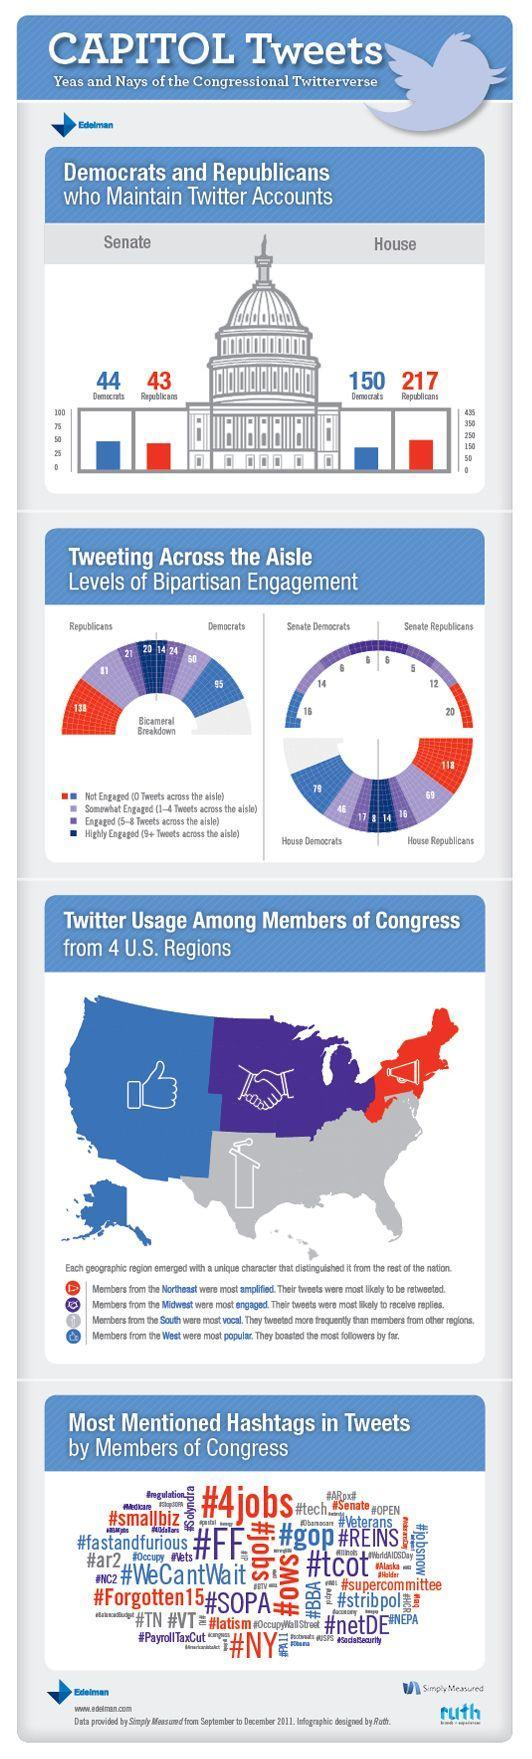Which region were found to tweet more often than the other places?
Answer the question with a short phrase. South What is the number of Republican Senators not using Twitter? 20 Which was the most mentioned hashtag in Tweets by Congressmen? #4jobs, #FF What was the number of Democrats highly engaged in tweeting, 20, 14, or 24? 14 Who has a higher number of Twitter accounts in the House, Democrats or Republicans? Republicans Who has a higher number of Twitter accounts in the Senate, Democrats or Republicans? Democrats What is the number of Democratic Senators not using Twitter? 16 What is the total number of Republicans representatives in the House that use Twitter? 99 